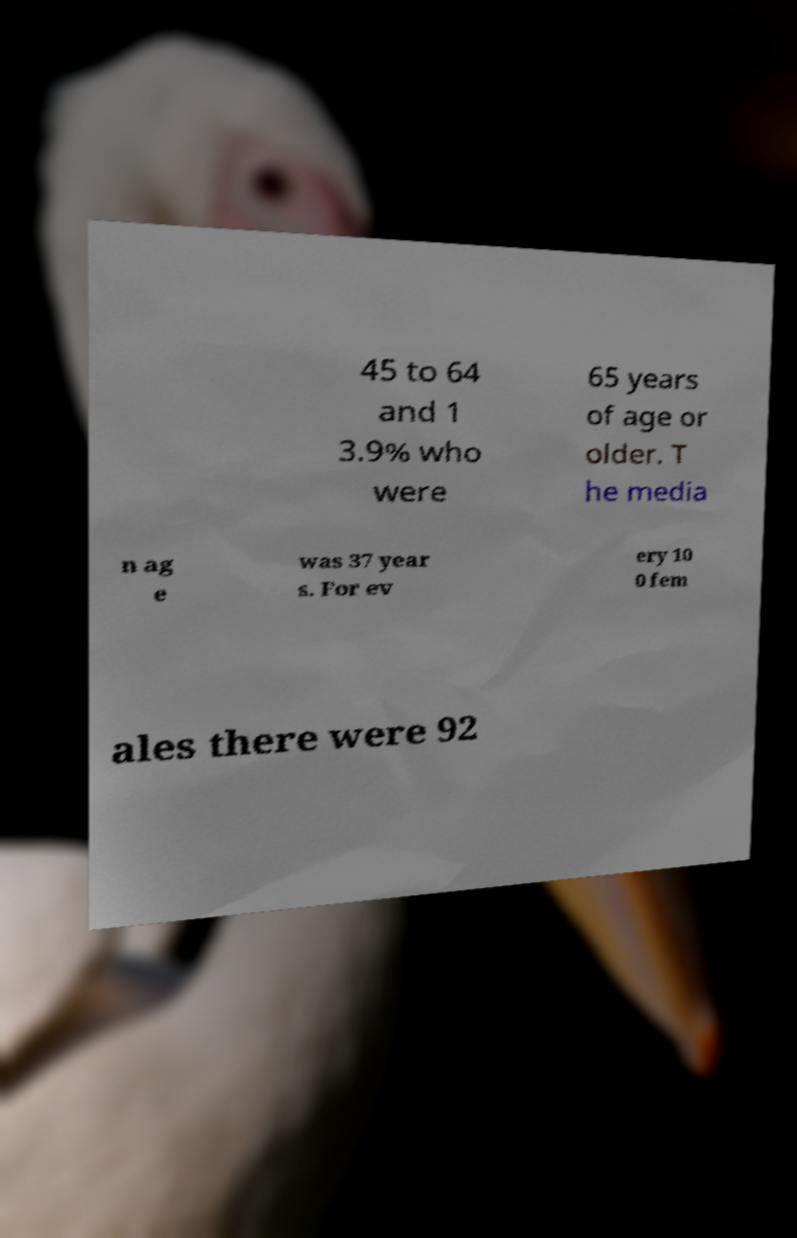Can you accurately transcribe the text from the provided image for me? 45 to 64 and 1 3.9% who were 65 years of age or older. T he media n ag e was 37 year s. For ev ery 10 0 fem ales there were 92 